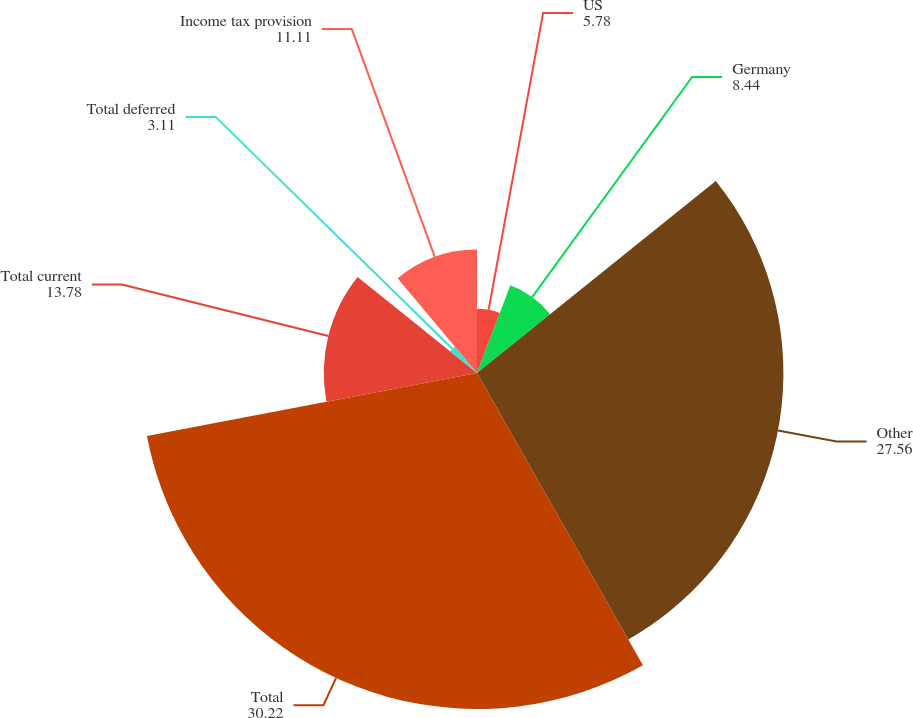<chart> <loc_0><loc_0><loc_500><loc_500><pie_chart><fcel>US<fcel>Germany<fcel>Other<fcel>Total<fcel>Total current<fcel>Total deferred<fcel>Income tax provision<nl><fcel>5.78%<fcel>8.44%<fcel>27.56%<fcel>30.22%<fcel>13.78%<fcel>3.11%<fcel>11.11%<nl></chart> 